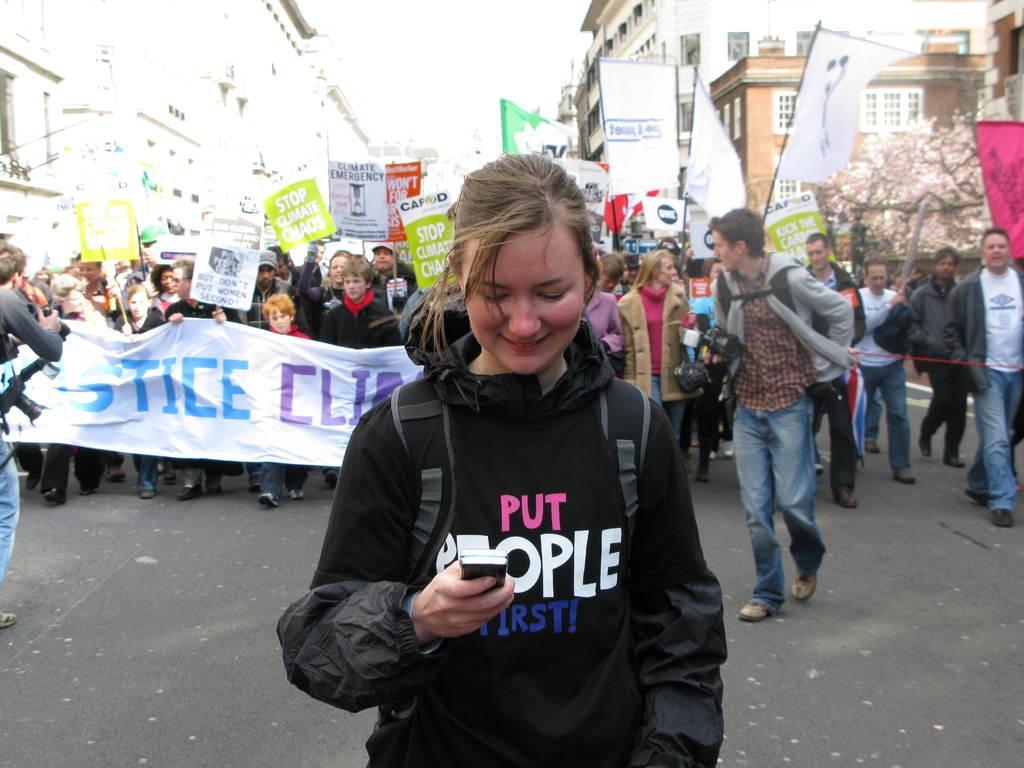In one or two sentences, can you explain what this image depicts? In front of the image there is a woman with a smile on her face is holding a mobile, behind the woman there are a few other people holding placards and banners and cameras are walking on the streets, behind them there are trees and buildings. 